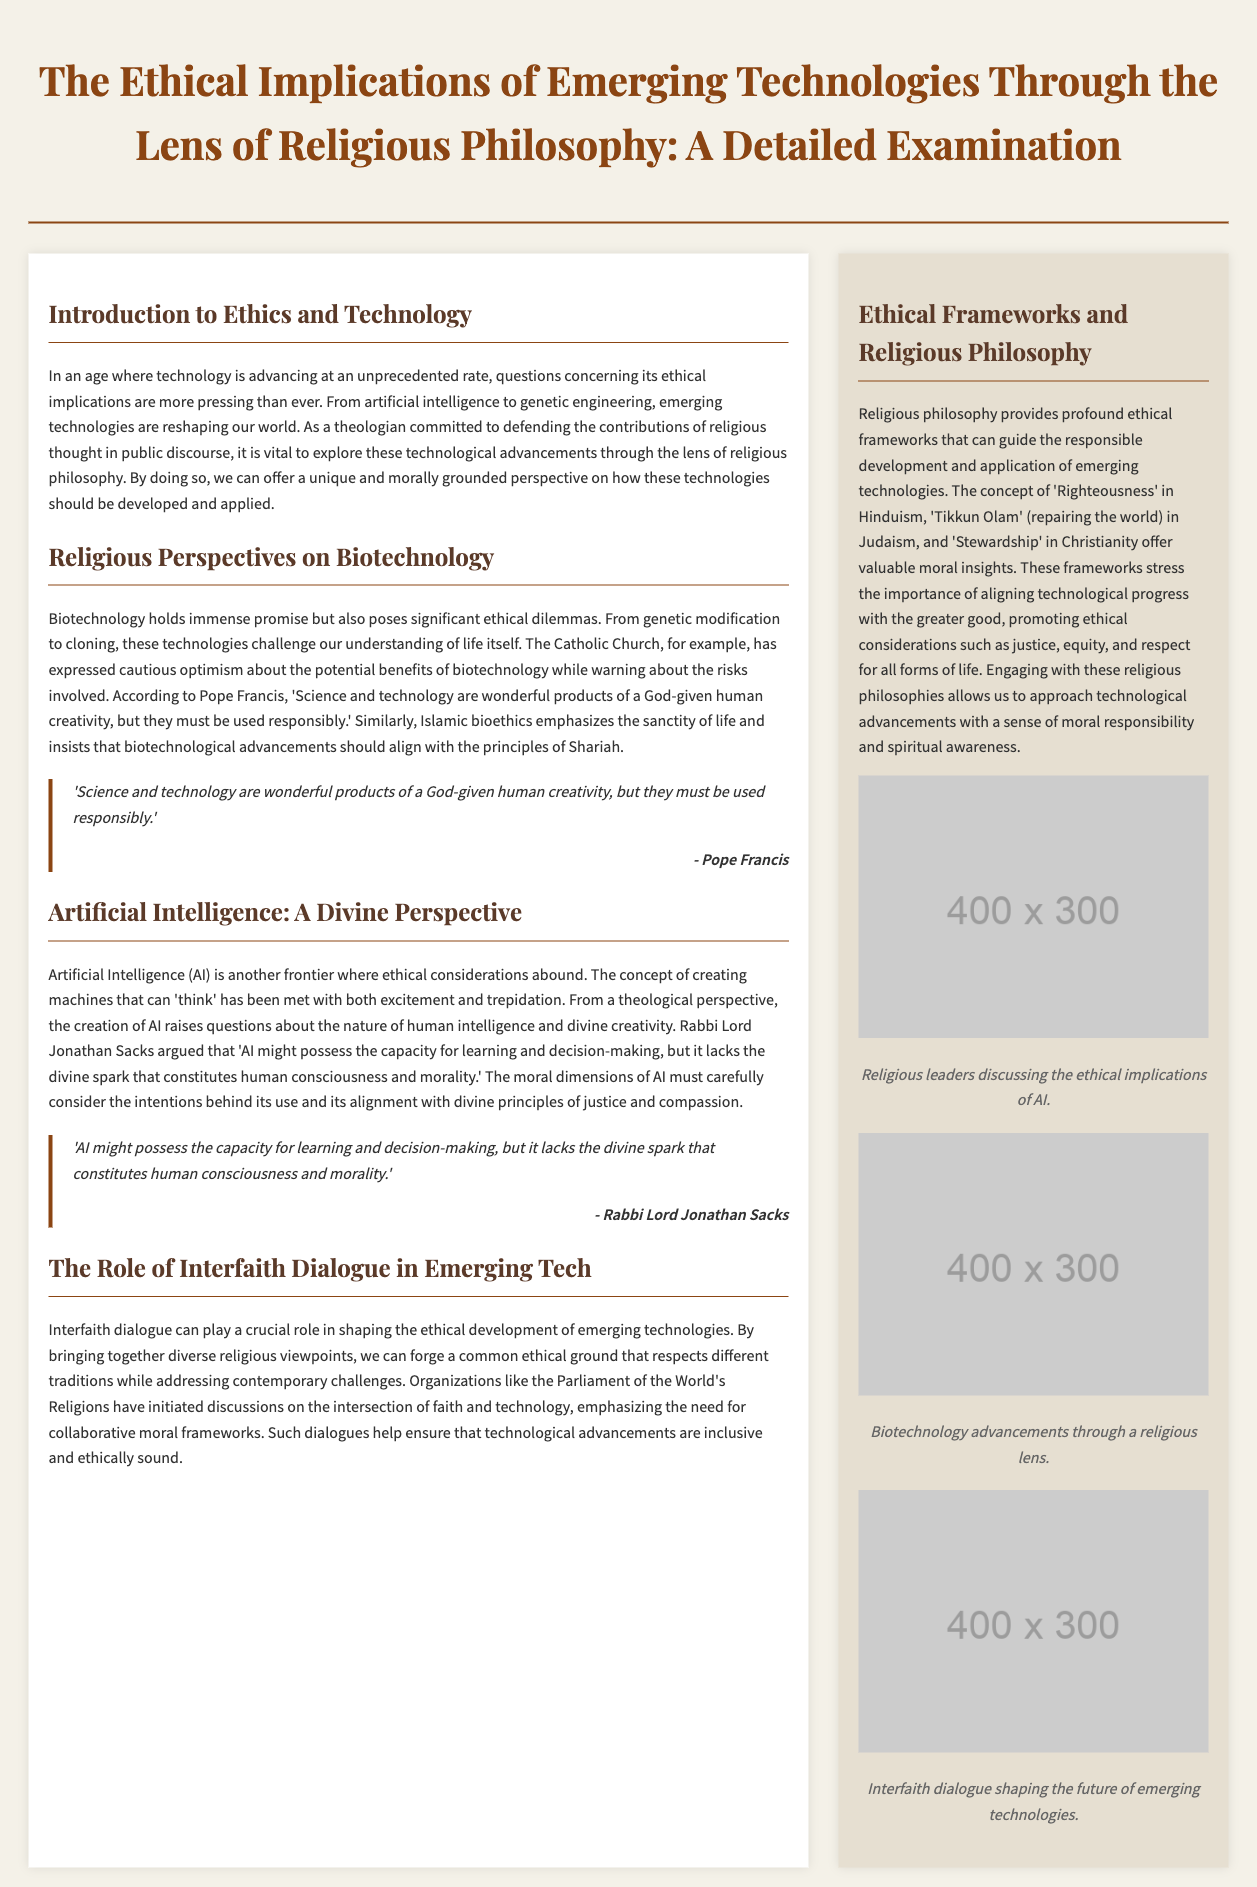what is the title of the document? The title of the document is presented prominently at the beginning, encapsulating the main theme.
Answer: The Ethical Implications of Emerging Technologies Through the Lens of Religious Philosophy: A Detailed Examination who expresses cautious optimism about biotechnology? The text mentions the Catholic Church and specifically cites Pope Francis as one who expresses this view.
Answer: Pope Francis what concept is emphasized in Islamic bioethics regarding biotechnology? The document states that Islamic bioethics emphasizes the sanctity of life concerning biotechnological advancements.
Answer: Sanctity of life who argued that AI lacks the divine spark? The document attributes this viewpoint to Rabbi Lord Jonathan Sacks in the discussion about AI.
Answer: Rabbi Lord Jonathan Sacks what ethical framework is mentioned in Hinduism? The document refers to the concept providing ethical guidance in Hinduism.
Answer: Righteousness how many images are included in the sidebar? The sidebar displays a certain number of images relating to the topic of technologies and religious discourse.
Answer: Three what is the main goal of interfaith dialogue regarding emerging technologies? The document discusses the objective of interfaith dialogue in shaping moral frameworks related to technology.
Answer: Forge a common ethical ground which organization is mentioned as initiating discussions on faith and technology? The text mentions a specific organization engaged in discussions about faith and technology in the context provided.
Answer: Parliament of the World's Religions 